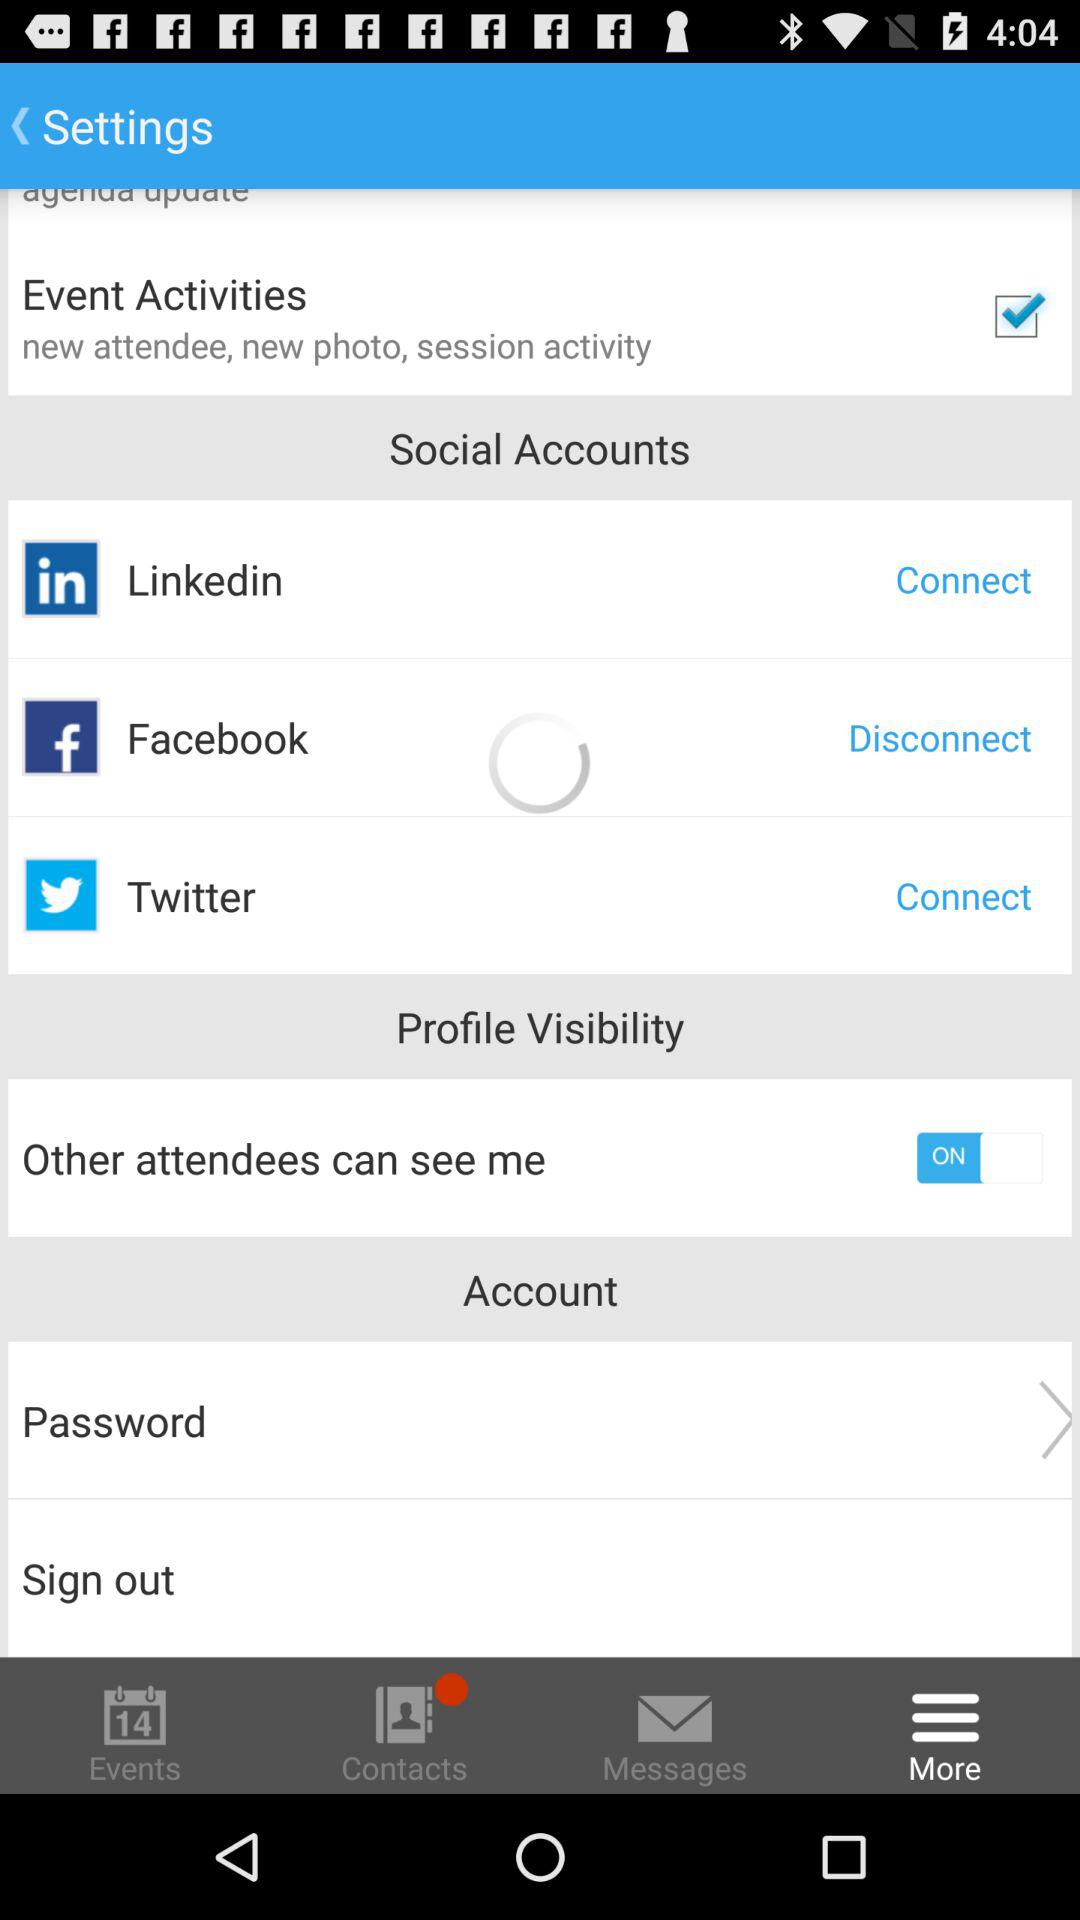Which two social accounts can be connected? The two social accounts that can be connected are "Linkedin" and "Twitter". 